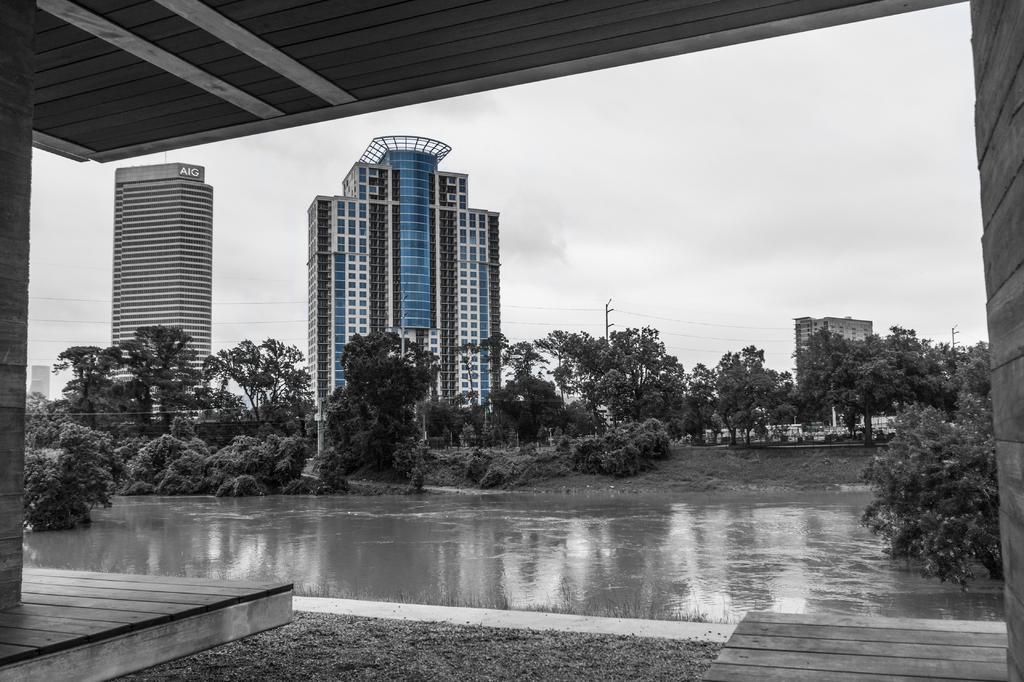In one or two sentences, can you explain what this image depicts? This image consists of water. In the front, there are many trees and buildings. At the bottom, there is a floor. In the background, we can see the sky and it looks too cloudy. 